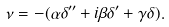<formula> <loc_0><loc_0><loc_500><loc_500>\nu = - ( \alpha \delta ^ { \prime \prime } + i \beta \delta ^ { \prime } + \gamma \delta ) .</formula> 